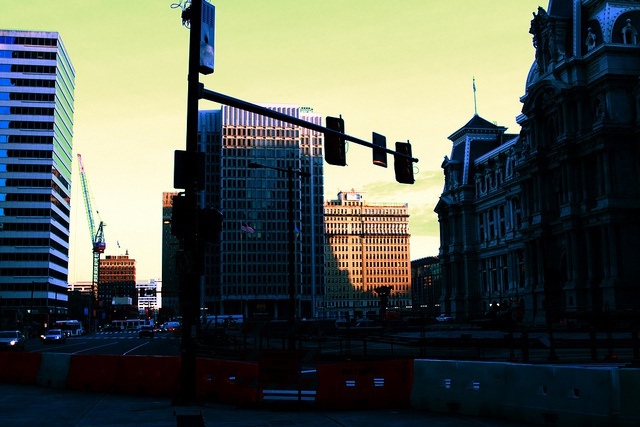Describe the objects in this image and their specific colors. I can see traffic light in khaki, black, navy, darkgray, and lightyellow tones, traffic light in khaki, black, navy, lightyellow, and blue tones, traffic light in khaki, black, lightyellow, navy, and darkgray tones, car in khaki, black, navy, and blue tones, and bus in khaki, black, navy, and blue tones in this image. 